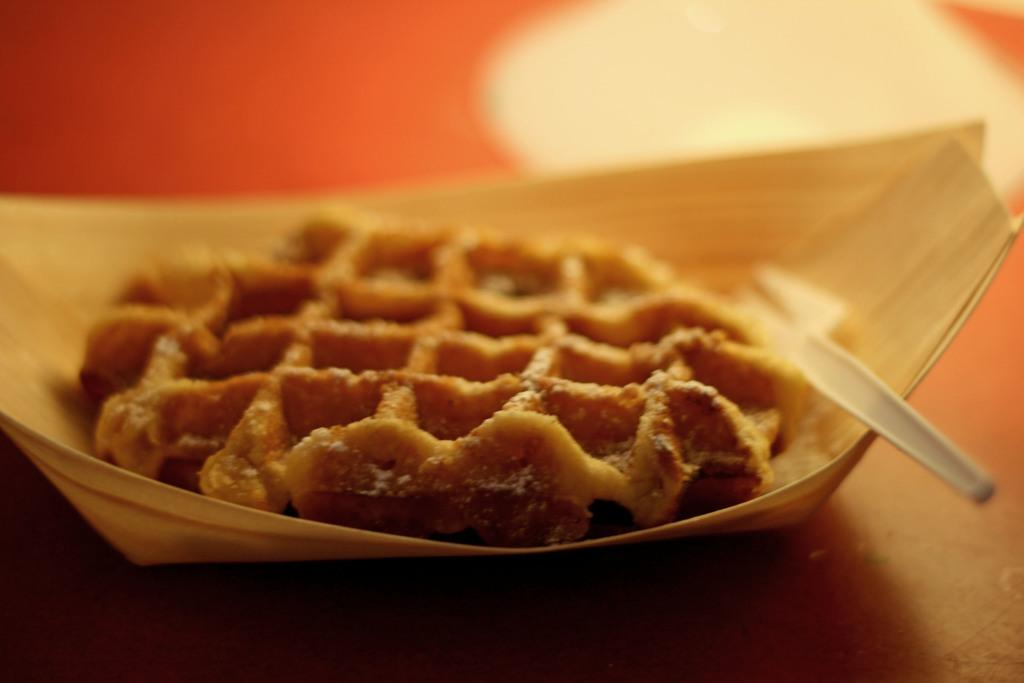What is in the bowl that is visible in the image? There is food in the bowl in the image. What utensil is present in the image? There is a spoon in the image. Where are the bowl and spoon located? The bowl and spoon are on a table in the image. Can you describe the background of the image? The background of the image is blurry. What type of glove can be seen hanging on the door in the image? There is no glove or door present in the image; it only features a bowl, food, a spoon, and a table. 